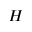Convert formula to latex. <formula><loc_0><loc_0><loc_500><loc_500>H</formula> 